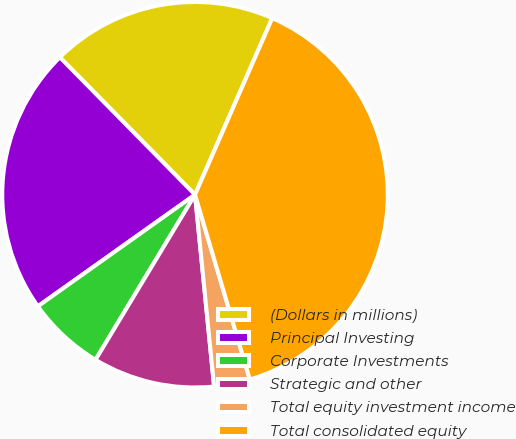Convert chart to OTSL. <chart><loc_0><loc_0><loc_500><loc_500><pie_chart><fcel>(Dollars in millions)<fcel>Principal Investing<fcel>Corporate Investments<fcel>Strategic and other<fcel>Total equity investment income<fcel>Total consolidated equity<nl><fcel>18.93%<fcel>22.46%<fcel>6.54%<fcel>10.21%<fcel>3.01%<fcel>38.85%<nl></chart> 